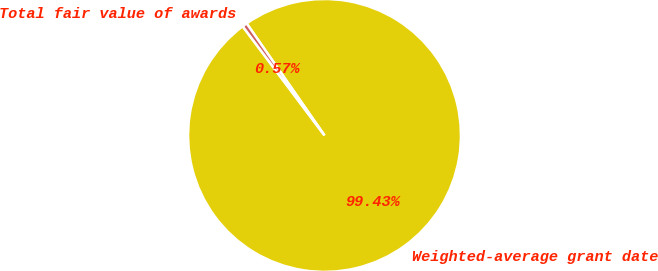Convert chart. <chart><loc_0><loc_0><loc_500><loc_500><pie_chart><fcel>Weighted-average grant date<fcel>Total fair value of awards<nl><fcel>99.43%<fcel>0.57%<nl></chart> 